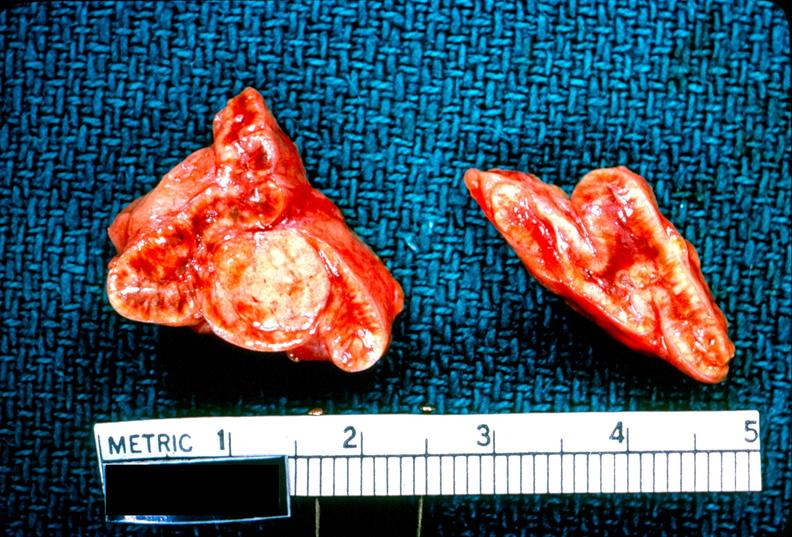s myocardium present?
Answer the question using a single word or phrase. No 